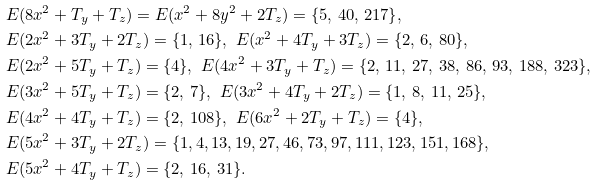Convert formula to latex. <formula><loc_0><loc_0><loc_500><loc_500>& E ( 8 x ^ { 2 } + T _ { y } + T _ { z } ) = E ( x ^ { 2 } + 8 y ^ { 2 } + 2 T _ { z } ) = \{ 5 , \, 4 0 , \, 2 1 7 \} , \\ & E ( 2 x ^ { 2 } + 3 T _ { y } + 2 T _ { z } ) = \{ 1 , \, 1 6 \} , \ E ( x ^ { 2 } + 4 T _ { y } + 3 T _ { z } ) = \{ 2 , \, 6 , \, 8 0 \} , \\ & E ( 2 x ^ { 2 } + 5 T _ { y } + T _ { z } ) = \{ 4 \} , \ E ( 4 x ^ { 2 } + 3 T _ { y } + T _ { z } ) = \{ 2 , \, 1 1 , \, 2 7 , \, 3 8 , \, 8 6 , \, 9 3 , \, 1 8 8 , \, 3 2 3 \} , \\ & E ( 3 x ^ { 2 } + 5 T _ { y } + T _ { z } ) = \{ 2 , \, 7 \} , \ E ( 3 x ^ { 2 } + 4 T _ { y } + 2 T _ { z } ) = \{ 1 , \, 8 , \, 1 1 , \, 2 5 \} , \\ & E ( 4 x ^ { 2 } + 4 T _ { y } + T _ { z } ) = \{ 2 , \, 1 0 8 \} , \ E ( 6 x ^ { 2 } + 2 T _ { y } + T _ { z } ) = \{ 4 \} , \\ & E ( 5 x ^ { 2 } + 3 T _ { y } + 2 T _ { z } ) = \{ 1 , 4 , 1 3 , 1 9 , 2 7 , 4 6 , 7 3 , 9 7 , 1 1 1 , 1 2 3 , 1 5 1 , 1 6 8 \} , \\ & E ( 5 x ^ { 2 } + 4 T _ { y } + T _ { z } ) = \{ 2 , \, 1 6 , \, 3 1 \} .</formula> 